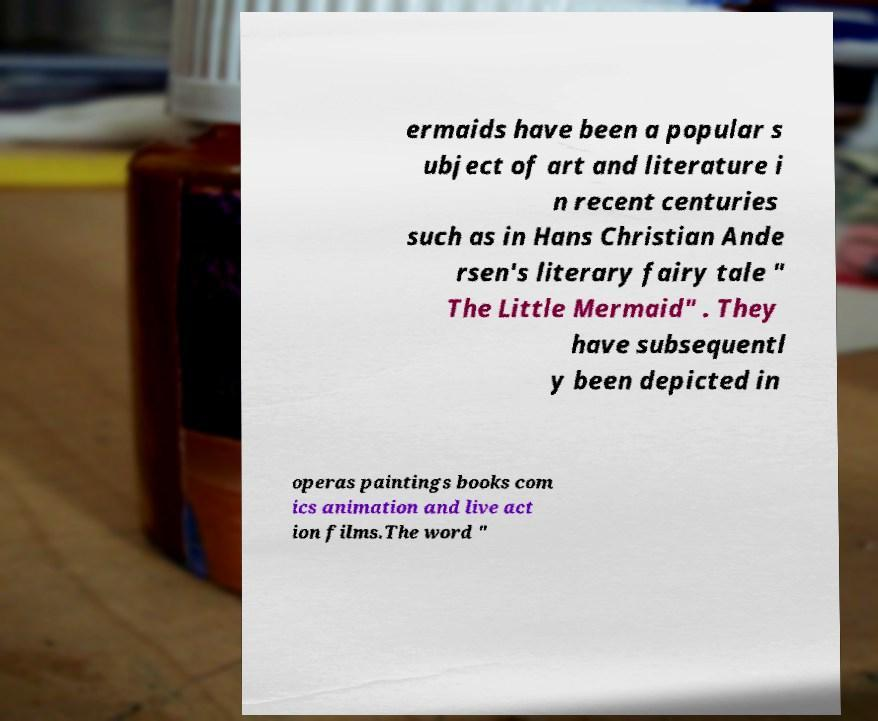Could you extract and type out the text from this image? ermaids have been a popular s ubject of art and literature i n recent centuries such as in Hans Christian Ande rsen's literary fairy tale " The Little Mermaid" . They have subsequentl y been depicted in operas paintings books com ics animation and live act ion films.The word " 